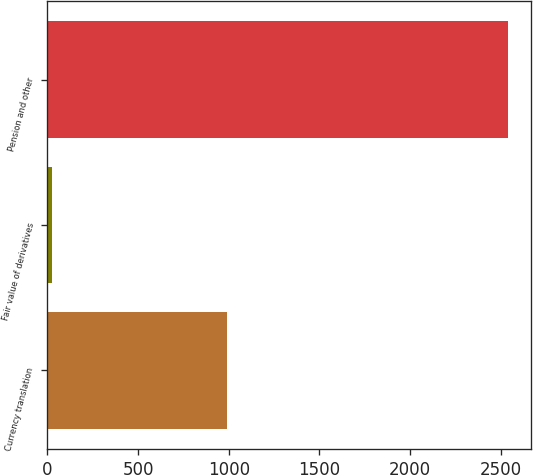<chart> <loc_0><loc_0><loc_500><loc_500><bar_chart><fcel>Currency translation<fcel>Fair value of derivatives<fcel>Pension and other<nl><fcel>993<fcel>26<fcel>2538<nl></chart> 